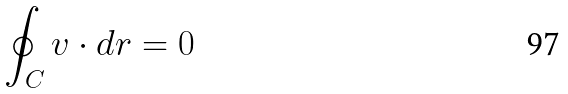<formula> <loc_0><loc_0><loc_500><loc_500>\oint _ { C } v \cdot d r = 0</formula> 